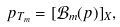Convert formula to latex. <formula><loc_0><loc_0><loc_500><loc_500>p _ { T _ { m } } = [ { \mathcal { B } } _ { m } ( p ) ] _ { X } ,</formula> 